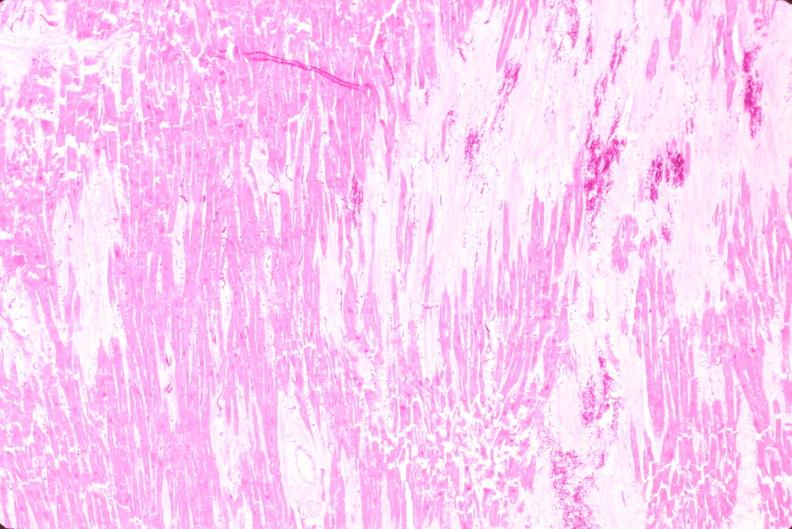does this image show heart, old myocardial infarction with fibrosis, he?
Answer the question using a single word or phrase. Yes 